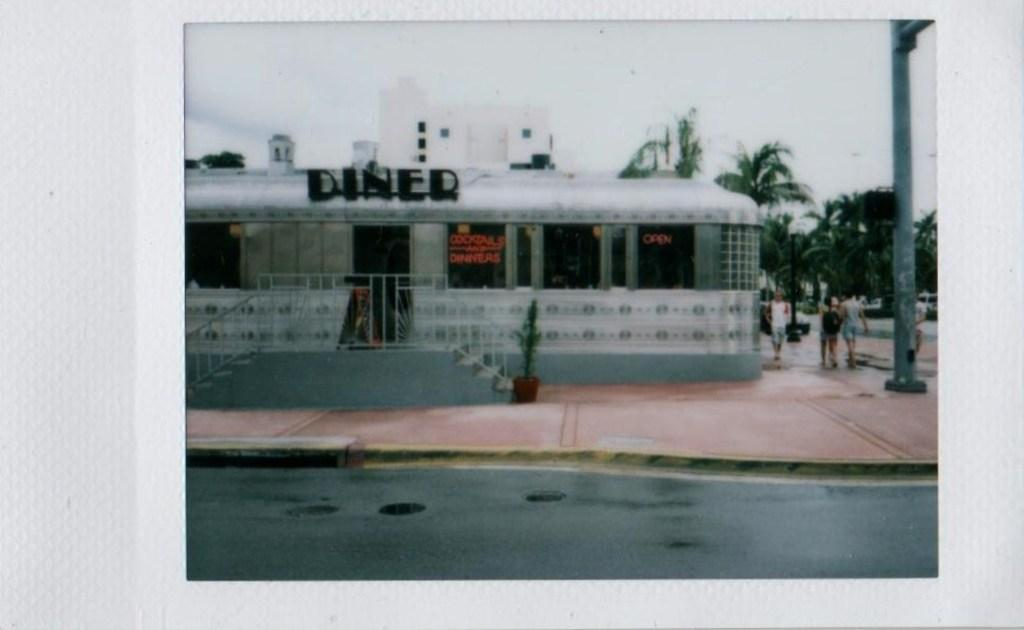What is the main subject of the image? The main subject of the image is a photo of buildings. What else can be seen in the image besides the buildings? There are trees and a pole visible in the image. What are the people in the image doing? People are walking on the pavement in the image. Where is the faucet located in the image? There is no faucet present in the image. What type of organization is depicted in the image? The image does not depict any organization; it shows buildings, trees, a pole, and people walking on the pavement. 